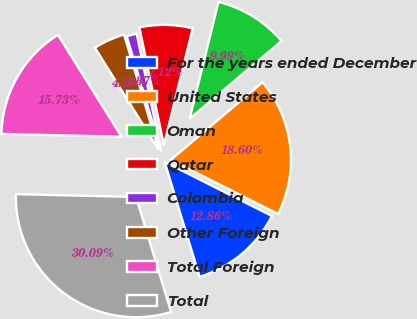Convert chart. <chart><loc_0><loc_0><loc_500><loc_500><pie_chart><fcel>For the years ended December<fcel>United States<fcel>Oman<fcel>Qatar<fcel>Colombia<fcel>Other Foreign<fcel>Total Foreign<fcel>Total<nl><fcel>12.86%<fcel>18.6%<fcel>9.99%<fcel>7.12%<fcel>1.37%<fcel>4.25%<fcel>15.73%<fcel>30.09%<nl></chart> 